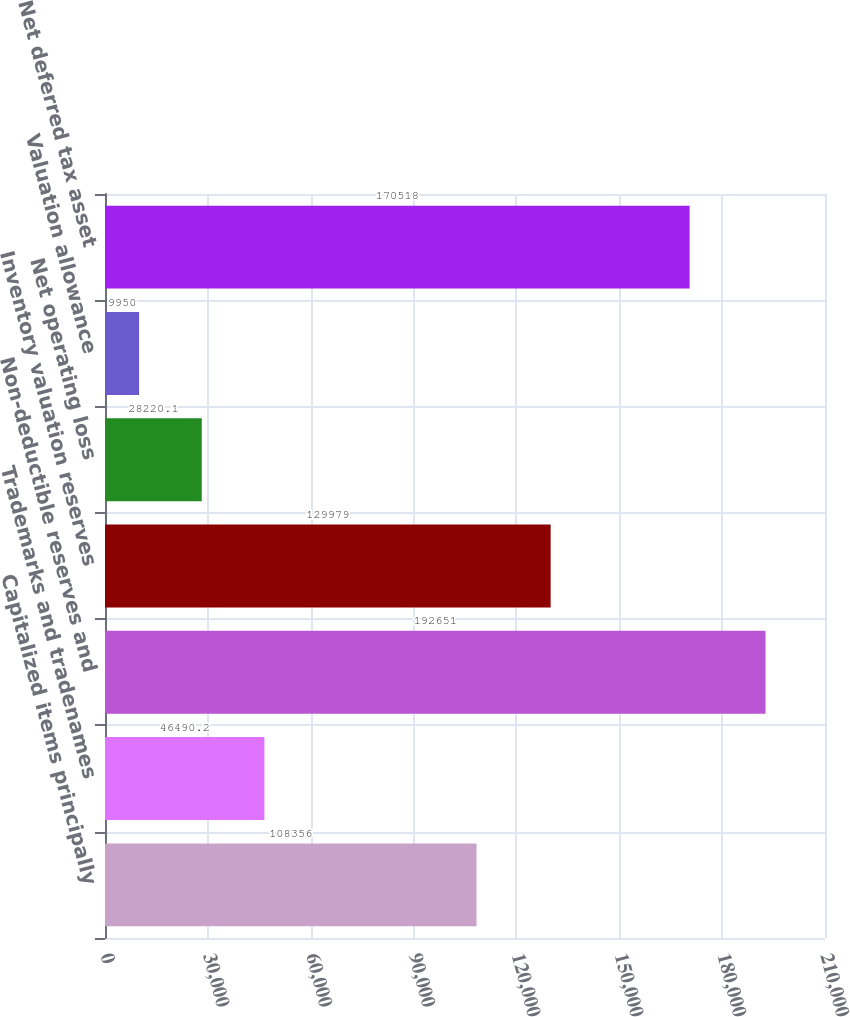Convert chart to OTSL. <chart><loc_0><loc_0><loc_500><loc_500><bar_chart><fcel>Capitalized items principally<fcel>Trademarks and tradenames<fcel>Non-deductible reserves and<fcel>Inventory valuation reserves<fcel>Net operating loss<fcel>Valuation allowance<fcel>Net deferred tax asset<nl><fcel>108356<fcel>46490.2<fcel>192651<fcel>129979<fcel>28220.1<fcel>9950<fcel>170518<nl></chart> 